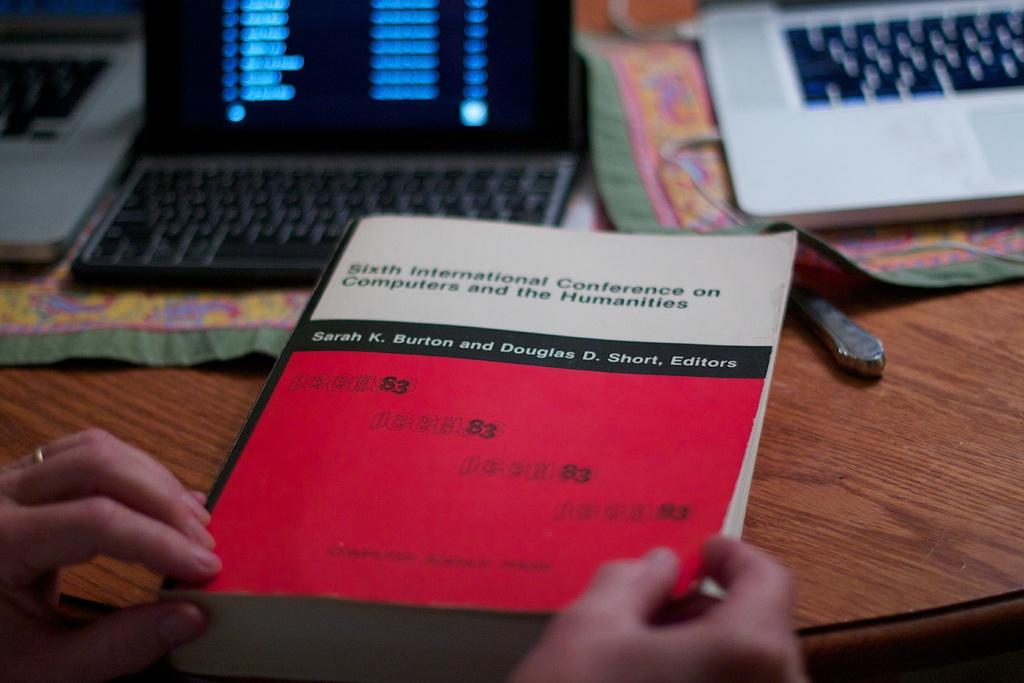<image>
Relay a brief, clear account of the picture shown. A book titled "Sixth International Conference on Computers and the Humanities" 